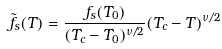<formula> <loc_0><loc_0><loc_500><loc_500>\tilde { f } _ { s } ( T ) = \frac { f _ { s } ( T _ { 0 } ) } { ( T _ { c } - T _ { 0 } ) ^ { \nu / 2 } } ( T _ { c } - T ) ^ { \nu / 2 } \,</formula> 